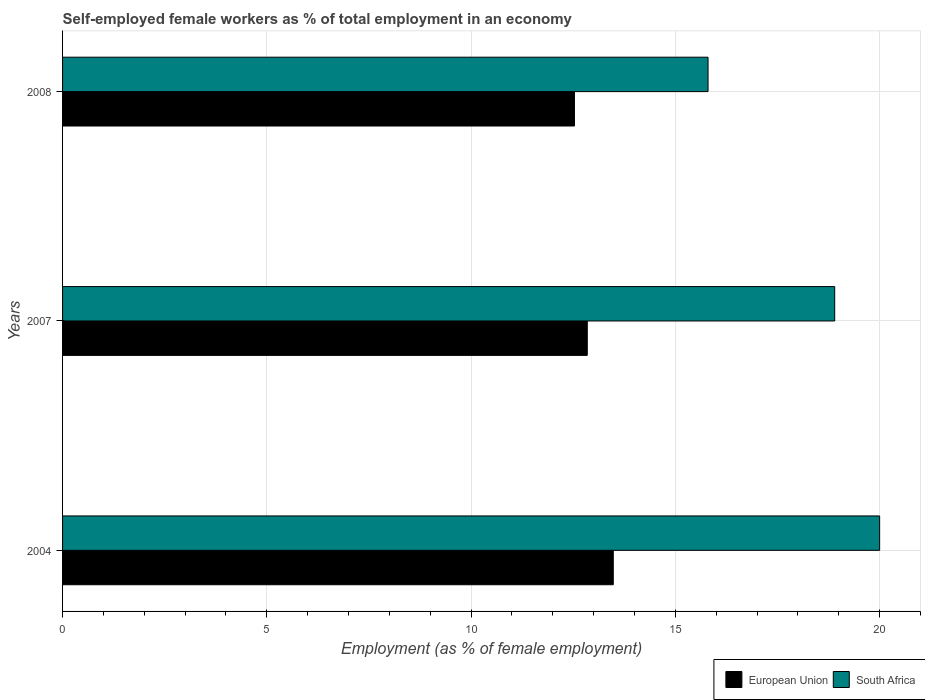Are the number of bars per tick equal to the number of legend labels?
Give a very brief answer. Yes. Are the number of bars on each tick of the Y-axis equal?
Your answer should be very brief. Yes. How many bars are there on the 3rd tick from the top?
Your answer should be compact. 2. What is the label of the 2nd group of bars from the top?
Ensure brevity in your answer.  2007. What is the percentage of self-employed female workers in South Africa in 2008?
Your answer should be very brief. 15.8. Across all years, what is the maximum percentage of self-employed female workers in European Union?
Keep it short and to the point. 13.48. Across all years, what is the minimum percentage of self-employed female workers in European Union?
Offer a very short reply. 12.53. In which year was the percentage of self-employed female workers in South Africa maximum?
Provide a succinct answer. 2004. In which year was the percentage of self-employed female workers in European Union minimum?
Ensure brevity in your answer.  2008. What is the total percentage of self-employed female workers in South Africa in the graph?
Make the answer very short. 54.7. What is the difference between the percentage of self-employed female workers in South Africa in 2004 and that in 2008?
Your answer should be very brief. 4.2. What is the difference between the percentage of self-employed female workers in European Union in 2008 and the percentage of self-employed female workers in South Africa in 2007?
Your answer should be very brief. -6.37. What is the average percentage of self-employed female workers in European Union per year?
Offer a terse response. 12.95. In the year 2004, what is the difference between the percentage of self-employed female workers in European Union and percentage of self-employed female workers in South Africa?
Offer a terse response. -6.52. What is the ratio of the percentage of self-employed female workers in South Africa in 2007 to that in 2008?
Keep it short and to the point. 1.2. What is the difference between the highest and the second highest percentage of self-employed female workers in South Africa?
Keep it short and to the point. 1.1. What is the difference between the highest and the lowest percentage of self-employed female workers in South Africa?
Offer a very short reply. 4.2. In how many years, is the percentage of self-employed female workers in European Union greater than the average percentage of self-employed female workers in European Union taken over all years?
Provide a short and direct response. 1. Is the sum of the percentage of self-employed female workers in European Union in 2004 and 2007 greater than the maximum percentage of self-employed female workers in South Africa across all years?
Keep it short and to the point. Yes. What does the 2nd bar from the top in 2007 represents?
Offer a terse response. European Union. What does the 2nd bar from the bottom in 2004 represents?
Provide a short and direct response. South Africa. How many years are there in the graph?
Offer a terse response. 3. Are the values on the major ticks of X-axis written in scientific E-notation?
Ensure brevity in your answer.  No. Where does the legend appear in the graph?
Offer a very short reply. Bottom right. What is the title of the graph?
Offer a terse response. Self-employed female workers as % of total employment in an economy. Does "French Polynesia" appear as one of the legend labels in the graph?
Your answer should be compact. No. What is the label or title of the X-axis?
Offer a very short reply. Employment (as % of female employment). What is the Employment (as % of female employment) in European Union in 2004?
Provide a short and direct response. 13.48. What is the Employment (as % of female employment) in South Africa in 2004?
Make the answer very short. 20. What is the Employment (as % of female employment) of European Union in 2007?
Offer a terse response. 12.84. What is the Employment (as % of female employment) in South Africa in 2007?
Keep it short and to the point. 18.9. What is the Employment (as % of female employment) in European Union in 2008?
Make the answer very short. 12.53. What is the Employment (as % of female employment) of South Africa in 2008?
Keep it short and to the point. 15.8. Across all years, what is the maximum Employment (as % of female employment) in European Union?
Offer a very short reply. 13.48. Across all years, what is the minimum Employment (as % of female employment) of European Union?
Make the answer very short. 12.53. Across all years, what is the minimum Employment (as % of female employment) of South Africa?
Your answer should be compact. 15.8. What is the total Employment (as % of female employment) in European Union in the graph?
Your response must be concise. 38.85. What is the total Employment (as % of female employment) in South Africa in the graph?
Ensure brevity in your answer.  54.7. What is the difference between the Employment (as % of female employment) in European Union in 2004 and that in 2007?
Your answer should be very brief. 0.64. What is the difference between the Employment (as % of female employment) in South Africa in 2004 and that in 2007?
Keep it short and to the point. 1.1. What is the difference between the Employment (as % of female employment) in European Union in 2004 and that in 2008?
Keep it short and to the point. 0.95. What is the difference between the Employment (as % of female employment) of European Union in 2007 and that in 2008?
Your response must be concise. 0.31. What is the difference between the Employment (as % of female employment) in South Africa in 2007 and that in 2008?
Offer a terse response. 3.1. What is the difference between the Employment (as % of female employment) of European Union in 2004 and the Employment (as % of female employment) of South Africa in 2007?
Keep it short and to the point. -5.42. What is the difference between the Employment (as % of female employment) of European Union in 2004 and the Employment (as % of female employment) of South Africa in 2008?
Keep it short and to the point. -2.32. What is the difference between the Employment (as % of female employment) of European Union in 2007 and the Employment (as % of female employment) of South Africa in 2008?
Keep it short and to the point. -2.96. What is the average Employment (as % of female employment) of European Union per year?
Provide a succinct answer. 12.95. What is the average Employment (as % of female employment) in South Africa per year?
Your answer should be very brief. 18.23. In the year 2004, what is the difference between the Employment (as % of female employment) of European Union and Employment (as % of female employment) of South Africa?
Make the answer very short. -6.52. In the year 2007, what is the difference between the Employment (as % of female employment) in European Union and Employment (as % of female employment) in South Africa?
Offer a terse response. -6.06. In the year 2008, what is the difference between the Employment (as % of female employment) of European Union and Employment (as % of female employment) of South Africa?
Make the answer very short. -3.27. What is the ratio of the Employment (as % of female employment) of European Union in 2004 to that in 2007?
Provide a short and direct response. 1.05. What is the ratio of the Employment (as % of female employment) of South Africa in 2004 to that in 2007?
Give a very brief answer. 1.06. What is the ratio of the Employment (as % of female employment) of European Union in 2004 to that in 2008?
Make the answer very short. 1.08. What is the ratio of the Employment (as % of female employment) of South Africa in 2004 to that in 2008?
Keep it short and to the point. 1.27. What is the ratio of the Employment (as % of female employment) in South Africa in 2007 to that in 2008?
Your answer should be compact. 1.2. What is the difference between the highest and the second highest Employment (as % of female employment) of European Union?
Provide a succinct answer. 0.64. What is the difference between the highest and the lowest Employment (as % of female employment) of European Union?
Your response must be concise. 0.95. 